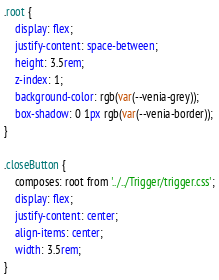<code> <loc_0><loc_0><loc_500><loc_500><_CSS_>.root {
    display: flex;
    justify-content: space-between;
    height: 3.5rem;
    z-index: 1;
    background-color: rgb(var(--venia-grey));
    box-shadow: 0 1px rgb(var(--venia-border));
}

.closeButton {
    composes: root from '../../Trigger/trigger.css';
    display: flex;
    justify-content: center;
    align-items: center;
    width: 3.5rem;
}
</code> 